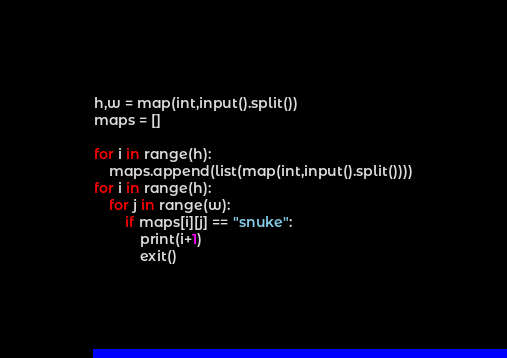Convert code to text. <code><loc_0><loc_0><loc_500><loc_500><_Python_>h,w = map(int,input().split())
maps = []

for i in range(h):
    maps.append(list(map(int,input().split())))
for i in range(h):
    for j in range(w):
        if maps[i][j] == "snuke":
            print(i+1)
            exit()</code> 